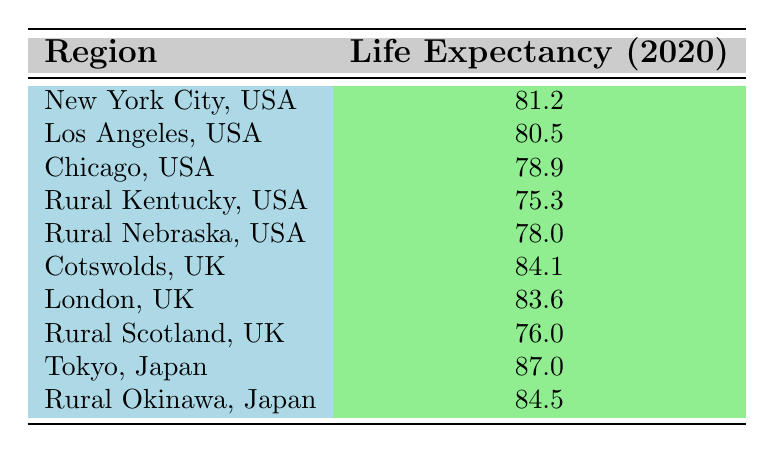What is the average life expectancy in New York City, USA? According to the table, the average life expectancy in New York City in 2020 is explicitly listed as 81.2.
Answer: 81.2 Which region has the lowest life expectancy? The table clearly shows that Rural Kentucky, USA has the lowest life expectancy at 75.3 when comparing all listed regions.
Answer: Rural Kentucky, USA What is the difference in life expectancy between Tokyo, Japan, and Chicago, USA? Tokyo has a life expectancy of 87.0 and Chicago has 78.9. The difference is 87.0 - 78.9 = 8.1.
Answer: 8.1 Is the average life expectancy of cities generally higher than rural areas in the provided data? Comparing urban and rural areas in the table, urban areas (like New York City, Los Angeles, Chicago) have higher life expectancies than rural areas (like Rural Kentucky and Rural Scotland), so yes, the average life expectancy of urban areas is generally higher.
Answer: Yes What is the average life expectancy of rural areas only? The rural areas listed are Rural Kentucky (75.3), Rural Nebraska (78.0), Rural Scotland (76.0), and Rural Okinawa (84.5). To find the average, we sum them: 75.3 + 78.0 + 76.0 + 84.5 = 313.8, and divide by the number of rural areas (4). 313.8 / 4 = 78.45.
Answer: 78.45 Which region's life expectancy exceeded 80 years? The table indicates that New York City (81.2), Los Angeles (80.5), Cotswolds (84.1), London (83.6), Tokyo (87.0), and Rural Okinawa (84.5) all have life expectancies greater than 80 years, so multiple regions exceed this threshold.
Answer: Yes What is the combined life expectancy of Rural Nebraska and Rural Scotland? Rural Nebraska has an average life expectancy of 78.0 and Rural Scotland has 76.0. The combined life expectancy is 78.0 + 76.0 = 154.0.
Answer: 154.0 Is life expectancy in Cotswolds, UK higher than that of Los Angeles, USA? Cotswolds has a life expectancy of 84.1 while Los Angeles is at 80.5. Since 84.1 is greater than 80.5, Cotswolds does indeed have a higher life expectancy than Los Angeles.
Answer: Yes What is the highest life expectancy among all regions listed? When examining the data, Tokyo, Japan has the highest life expectancy at 87.0 years, which stands out above other regions in the table.
Answer: 87.0 